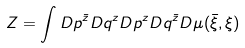Convert formula to latex. <formula><loc_0><loc_0><loc_500><loc_500>Z = \int D p ^ { \bar { z } } D q ^ { z } D p ^ { z } D q ^ { \bar { z } } D \mu ( { \bar { \xi } } , \xi )</formula> 